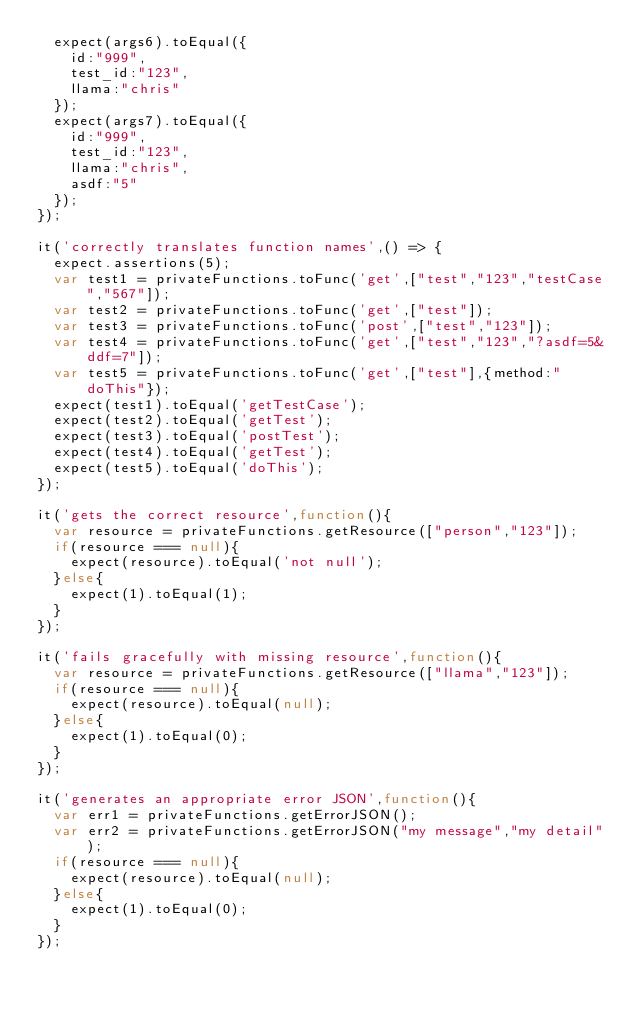Convert code to text. <code><loc_0><loc_0><loc_500><loc_500><_JavaScript_>	expect(args6).toEqual({
		id:"999",
		test_id:"123",
		llama:"chris"
	});
	expect(args7).toEqual({
		id:"999",
		test_id:"123",
		llama:"chris",
		asdf:"5"
	});
});

it('correctly translates function names',() => {
	expect.assertions(5);
	var test1 = privateFunctions.toFunc('get',["test","123","testCase","567"]);
	var test2 = privateFunctions.toFunc('get',["test"]);
	var test3 = privateFunctions.toFunc('post',["test","123"]);
	var test4 = privateFunctions.toFunc('get',["test","123","?asdf=5&ddf=7"]);
	var test5 = privateFunctions.toFunc('get',["test"],{method:"doThis"});
	expect(test1).toEqual('getTestCase');
	expect(test2).toEqual('getTest');
	expect(test3).toEqual('postTest');
	expect(test4).toEqual('getTest');
	expect(test5).toEqual('doThis');
});

it('gets the correct resource',function(){
	var resource = privateFunctions.getResource(["person","123"]);
	if(resource === null){
		expect(resource).toEqual('not null');
	}else{
		expect(1).toEqual(1);
	}
});

it('fails gracefully with missing resource',function(){
	var resource = privateFunctions.getResource(["llama","123"]);
	if(resource === null){
		expect(resource).toEqual(null);
	}else{
		expect(1).toEqual(0);
	}
});

it('generates an appropriate error JSON',function(){
	var err1 = privateFunctions.getErrorJSON();
	var err2 = privateFunctions.getErrorJSON("my message","my detail");
	if(resource === null){
		expect(resource).toEqual(null);
	}else{
		expect(1).toEqual(0);
	}
});</code> 